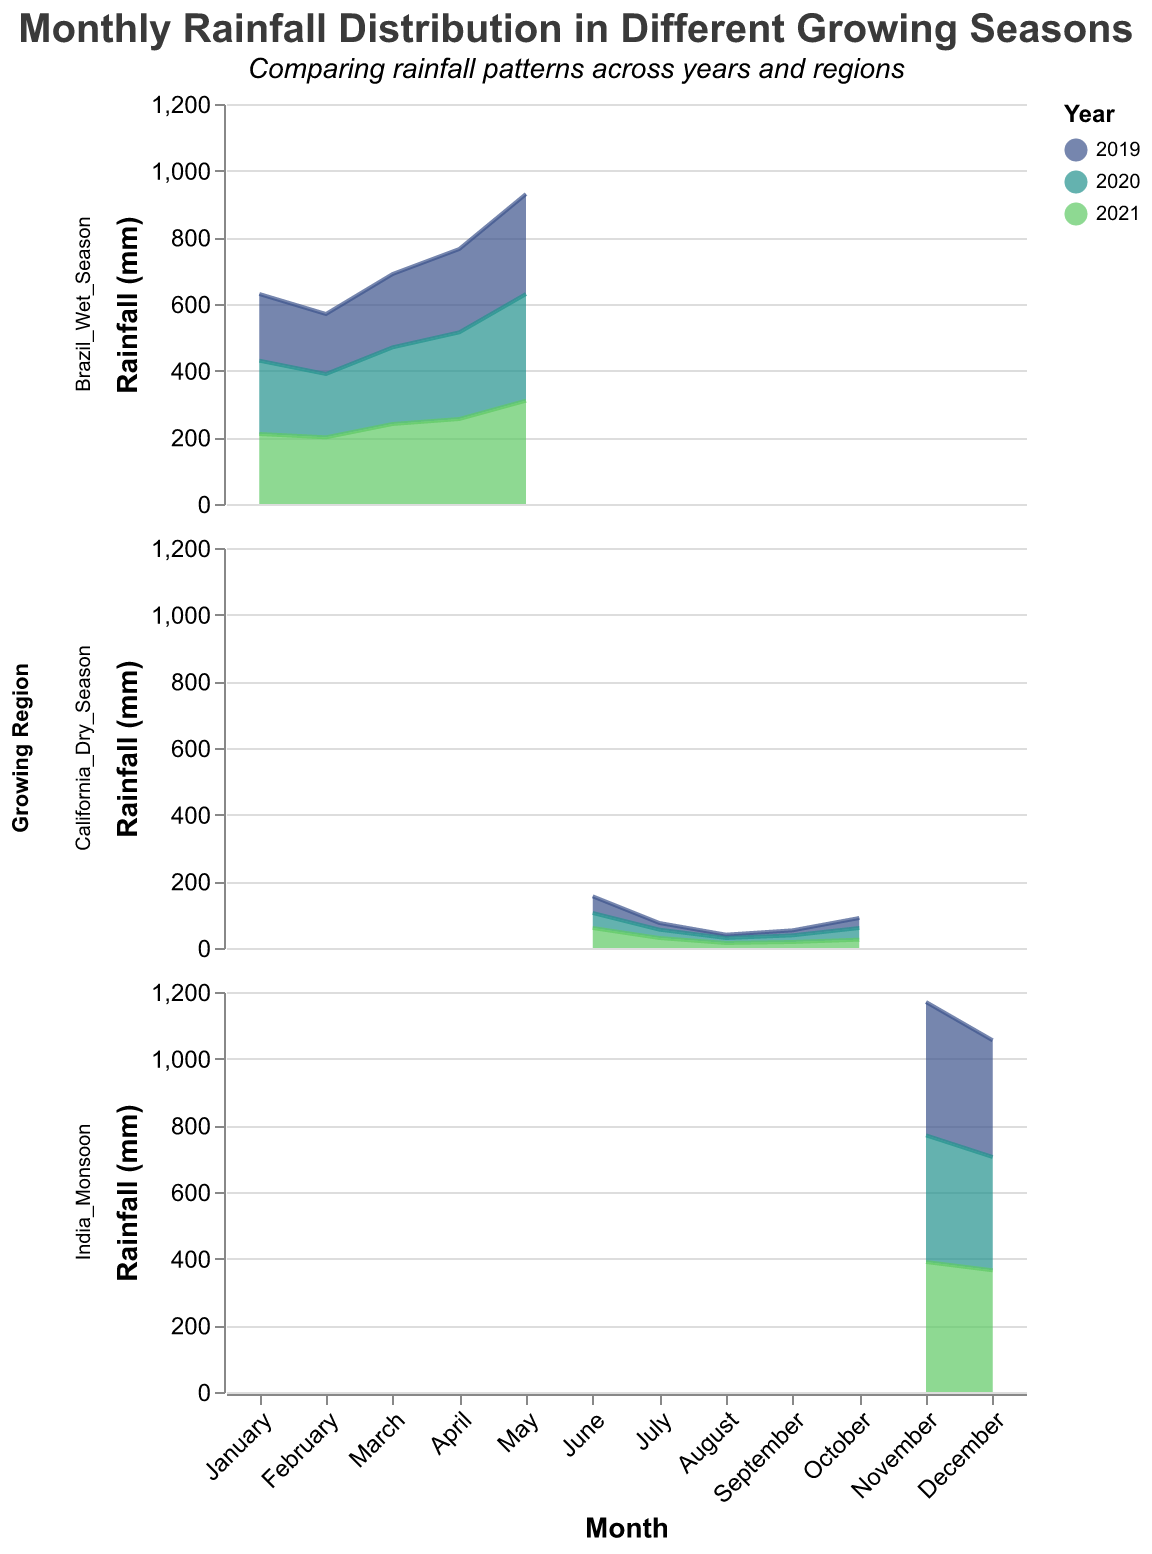What is the peak rainfall in the Brazil Wet Season in 2020? To find the peak rainfall, look at the Brazil Wet Season for the year 2020 and identify the highest rainfall value. The peak rainfall occurs in May with 320 mm.
Answer: 320 mm Which growing region has the highest monthly rainfall overall? Examine all subplots for the highest monthly rainfall value. The highest value is observed in India Monsoon with 400 mm in November 2019.
Answer: India Monsoon How does the rainfall in July compare between California Dry Season in 2019 and 2021? Compare the July rainfall for California Dry Season in the years 2019 and 2021. In 2019, it is 20 mm, and in 2021, it is 30 mm. Therefore, in 2021, July rainfall is higher by 10 mm.
Answer: 2021 is higher by 10 mm What is the average rainfall in the California Dry Season for any given year? Sum the monthly rainfall values for the California Dry Season within a single year and divide by the number of months (5). For instance, in 2019: (50+20+10+15+30) / 5 = 25 mm.
Answer: 25 mm Which year had the least rainfall during August in the California Dry Season? Compare the August rainfall values for the years 2019, 2020, and 2021. 2019 and 2021 both have 15 mm while 2020 has 10 mm. Therefore, 2020 had the least rainfall.
Answer: 2020 In which month does the rainfall peak in the India Monsoon season across the years? Examine the plots for the India Monsoon region and find the month with the highest rainfall. November consistently shows the highest rainfall, peaking at 400 mm in 2019.
Answer: November Is the rainfall pattern in the Brazil Wet Season consistent across the years? Evaluate the monthly rainfall trends for the Brazil Wet Season from 2019 to 2021. All three years show a similar pattern with steady increases towards May.
Answer: Yes How does the rainfall in May 2021 compare between Brazil Wet Season and India Monsoon? Look at the rainfall values for May 2021 in both regions. Brazil Wet Season records 310 mm, while India Monsoon does not have rainfall data for May.
Answer: Not applicable for India Monsoon Which region exhibits the most variability in monthly rainfall? Compare the rainfall ranges across the subplots. The India Monsoon region shows the most variability, ranging from 340 mm to 400 mm.
Answer: India Monsoon What is the total annual rainfall for the Brazil Wet Season in 2019? Sum the monthly rainfall values for Brazil Wet Season in 2019: 200+180+220+250+300 = 1150 mm.
Answer: 1150 mm 